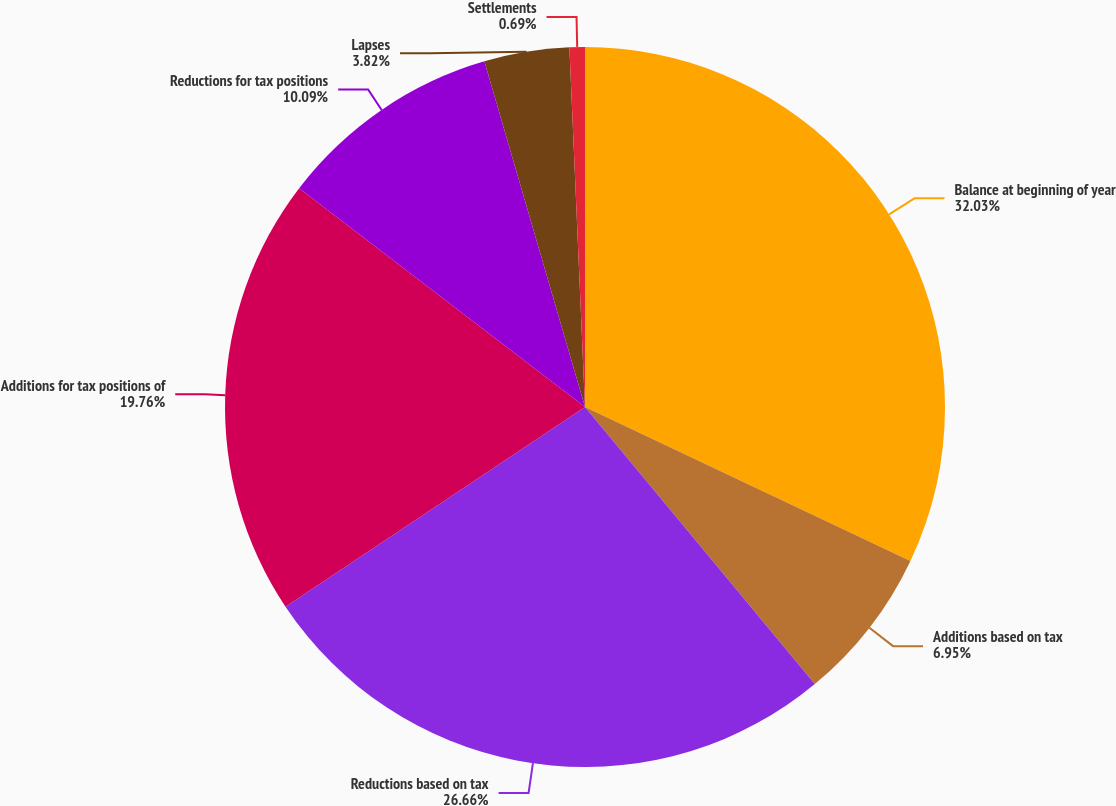<chart> <loc_0><loc_0><loc_500><loc_500><pie_chart><fcel>Balance at beginning of year<fcel>Additions based on tax<fcel>Reductions based on tax<fcel>Additions for tax positions of<fcel>Reductions for tax positions<fcel>Lapses<fcel>Settlements<nl><fcel>32.03%<fcel>6.95%<fcel>26.66%<fcel>19.76%<fcel>10.09%<fcel>3.82%<fcel>0.69%<nl></chart> 